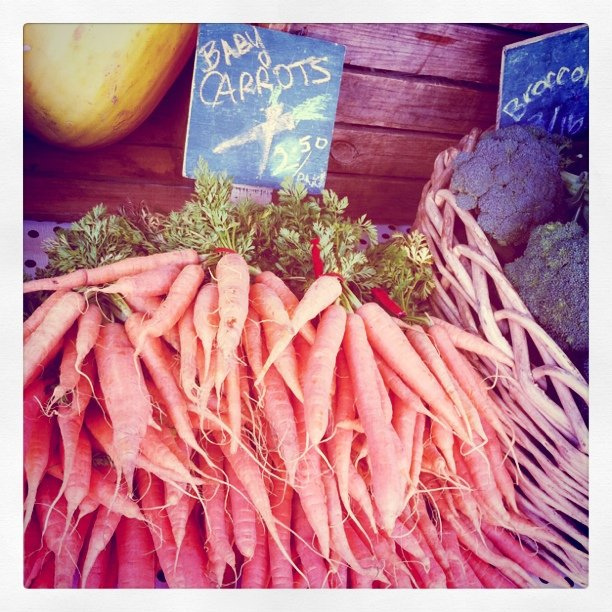This looks like a farmer's market. What are the benefits of shopping here? Shopping at a farmer's market usually means supporting local agriculture, getting access to fresh produce often with less environmental impact due to reduced transportation, and the opportunity to interact directly with growers. How can I tell if vegetables at a farmer's market are truly fresh? Fresh vegetables typically exhibit vibrant colors, firm textures, and overall appear lively and intact. You can often ask the sellers directly about the harvest date as well. 